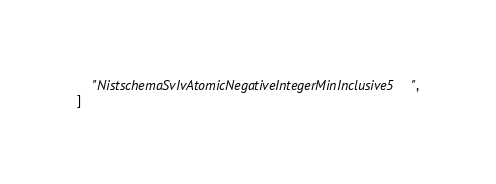Convert code to text. <code><loc_0><loc_0><loc_500><loc_500><_Python_>    "NistschemaSvIvAtomicNegativeIntegerMinInclusive5",
]
</code> 